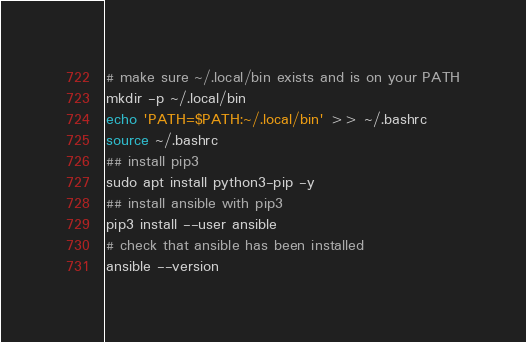<code> <loc_0><loc_0><loc_500><loc_500><_Bash_># make sure ~/.local/bin exists and is on your PATH
mkdir -p ~/.local/bin
echo 'PATH=$PATH:~/.local/bin' >> ~/.bashrc
source ~/.bashrc
## install pip3
sudo apt install python3-pip -y
## install ansible with pip3
pip3 install --user ansible
# check that ansible has been installed
ansible --version</code> 